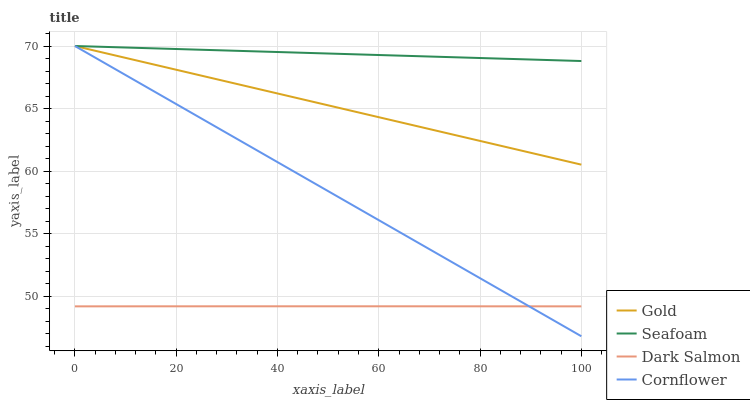Does Dark Salmon have the minimum area under the curve?
Answer yes or no. Yes. Does Seafoam have the maximum area under the curve?
Answer yes or no. Yes. Does Gold have the minimum area under the curve?
Answer yes or no. No. Does Gold have the maximum area under the curve?
Answer yes or no. No. Is Gold the smoothest?
Answer yes or no. Yes. Is Dark Salmon the roughest?
Answer yes or no. Yes. Is Seafoam the smoothest?
Answer yes or no. No. Is Seafoam the roughest?
Answer yes or no. No. Does Cornflower have the lowest value?
Answer yes or no. Yes. Does Gold have the lowest value?
Answer yes or no. No. Does Gold have the highest value?
Answer yes or no. Yes. Does Dark Salmon have the highest value?
Answer yes or no. No. Is Dark Salmon less than Gold?
Answer yes or no. Yes. Is Seafoam greater than Dark Salmon?
Answer yes or no. Yes. Does Gold intersect Seafoam?
Answer yes or no. Yes. Is Gold less than Seafoam?
Answer yes or no. No. Is Gold greater than Seafoam?
Answer yes or no. No. Does Dark Salmon intersect Gold?
Answer yes or no. No. 